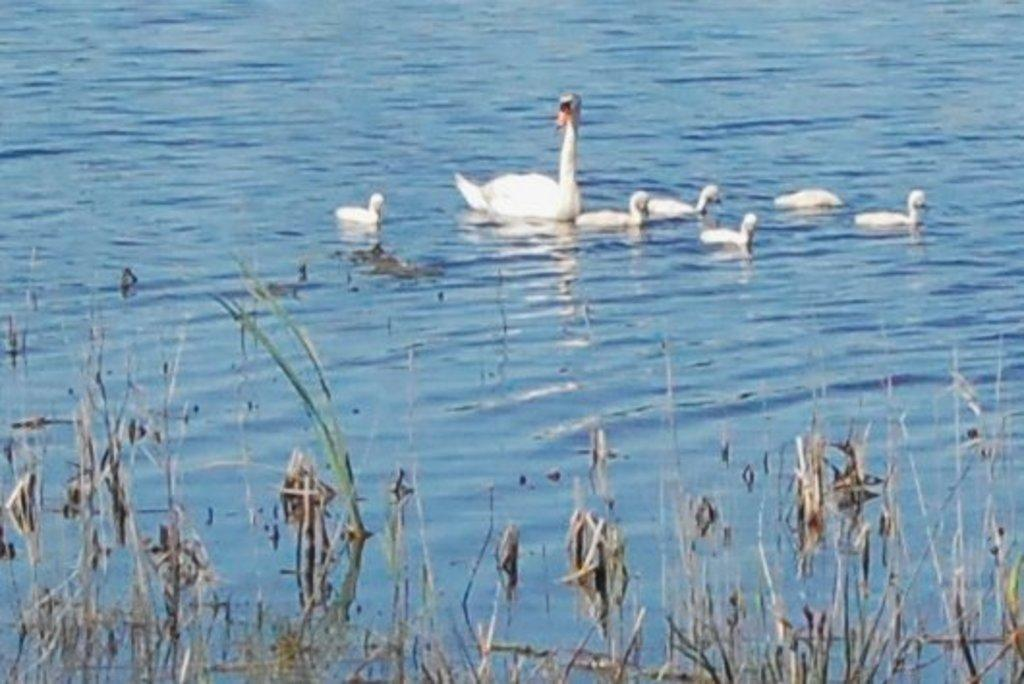What type of animal is present in the image? There is a duck in the image. Are there any baby ducks in the image? Yes, there are ducklings in the image. Where are the duck and ducklings located? The duck and ducklings are in the water. What can be seen growing in the water in the image? There are water plants visible in the image. What type of machine can be seen operating in the background of the image? There is no machine present in the image; it features a duck, ducklings, and water plants. Are there any giants visible in the image? There are no giants present in the image; it features a duck, ducklings, and water plants. 